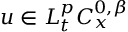<formula> <loc_0><loc_0><loc_500><loc_500>u \in L _ { t } ^ { p } C _ { x } ^ { 0 , \beta }</formula> 